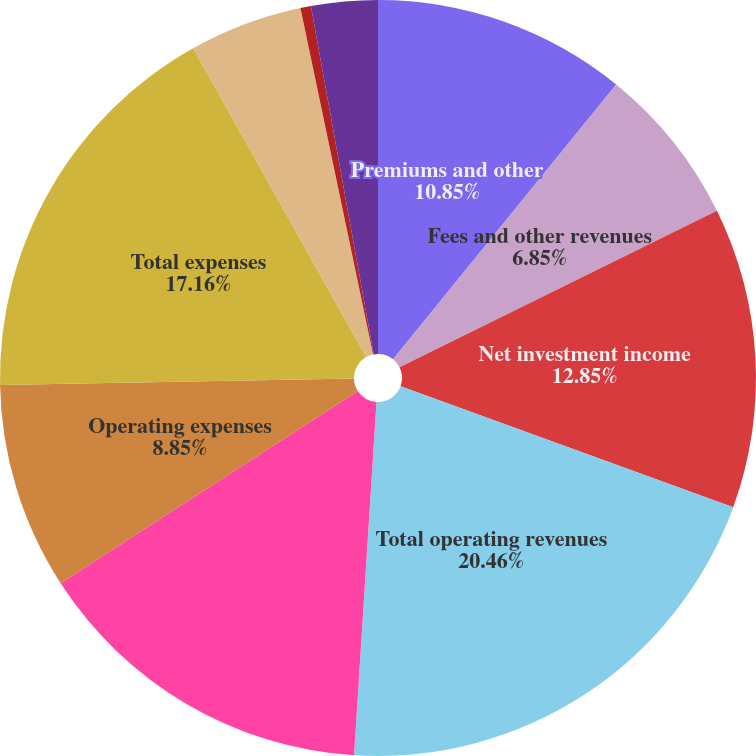Convert chart. <chart><loc_0><loc_0><loc_500><loc_500><pie_chart><fcel>Premiums and other<fcel>Fees and other revenues<fcel>Net investment income<fcel>Total operating revenues<fcel>Benefits claims and settlement<fcel>Operating expenses<fcel>Total expenses<fcel>Operating earnings before<fcel>Income taxes (benefits)<fcel>Operating earnings<nl><fcel>10.85%<fcel>6.85%<fcel>12.85%<fcel>20.46%<fcel>14.85%<fcel>8.85%<fcel>17.16%<fcel>4.84%<fcel>0.45%<fcel>2.84%<nl></chart> 